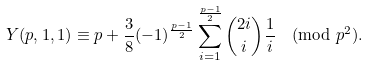Convert formula to latex. <formula><loc_0><loc_0><loc_500><loc_500>Y ( p , 1 , 1 ) \equiv p + \frac { 3 } { 8 } ( - 1 ) ^ { \frac { p - 1 } { 2 } } \sum _ { i = 1 } ^ { \frac { p - 1 } { 2 } } \binom { 2 i } { i } \frac { 1 } { i } \pmod { p ^ { 2 } } .</formula> 